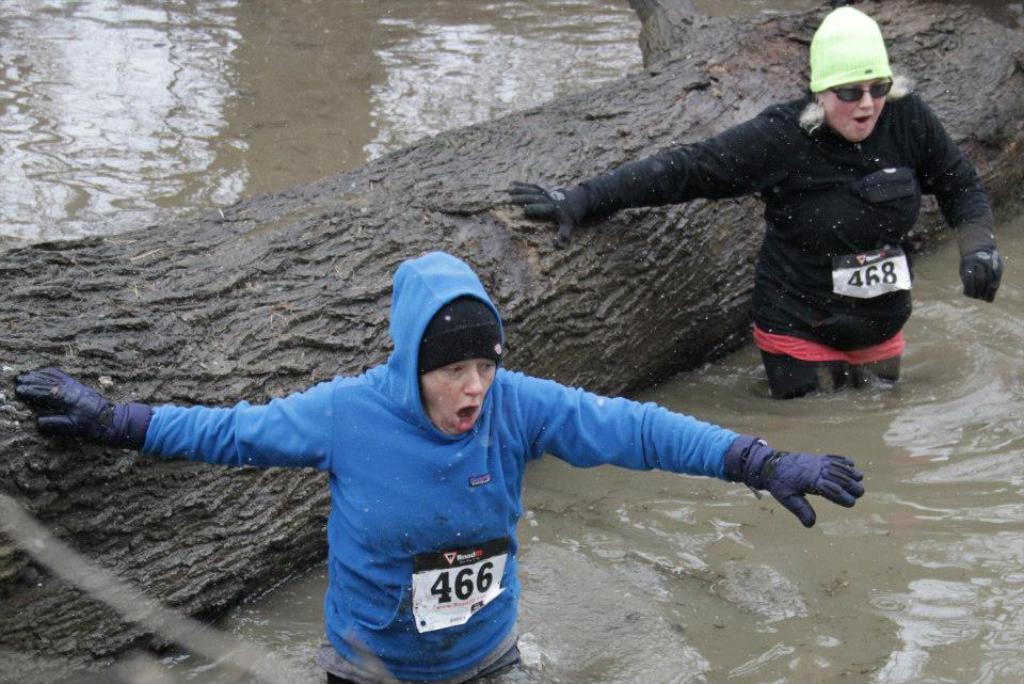Could you give a brief overview of what you see in this image? In this image we can see the bark of a tree. We can also see two persons wearing the hand gloves. We can see the pages with numbers. We can also see the water. 